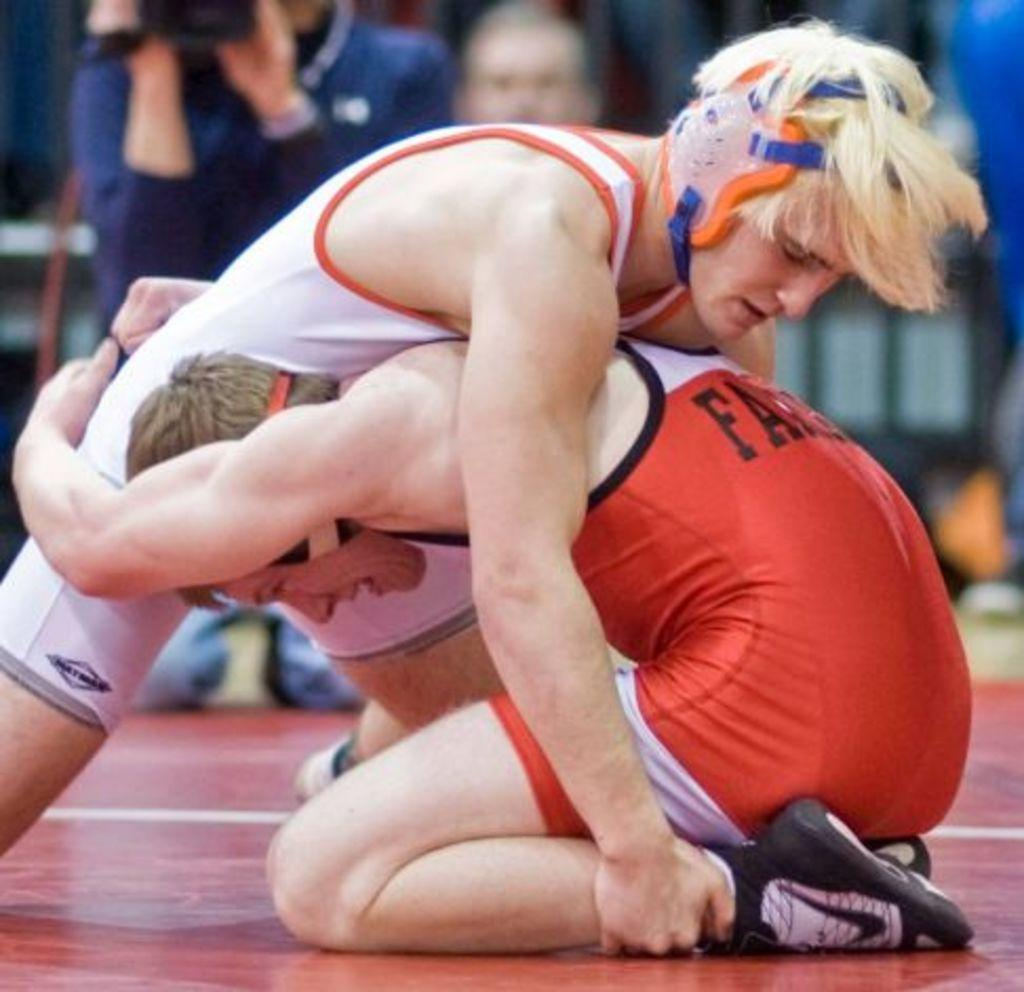<image>
Share a concise interpretation of the image provided. Two wrestlers in a match with one wearing an outfit with the letter F on it. 